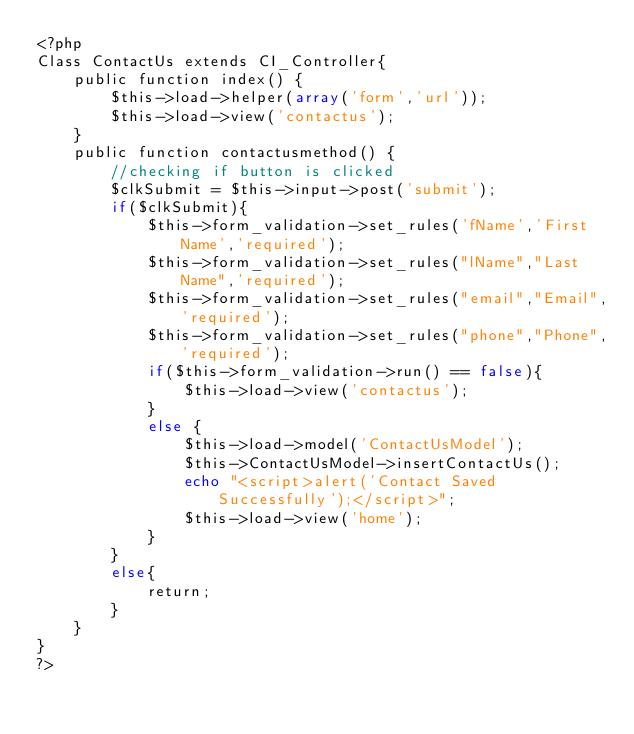Convert code to text. <code><loc_0><loc_0><loc_500><loc_500><_PHP_><?php
Class ContactUs extends CI_Controller{	
	public function index() {
		$this->load->helper(array('form','url'));
		$this->load->view('contactus');
	}
	public function contactusmethod() {
		//checking if button is clicked
		$clkSubmit = $this->input->post('submit');
		if($clkSubmit){			
			$this->form_validation->set_rules('fName','First Name','required');
			$this->form_validation->set_rules("lName","Last Name",'required');
			$this->form_validation->set_rules("email","Email",'required');
			$this->form_validation->set_rules("phone","Phone",'required');
			if($this->form_validation->run() == false){
				$this->load->view('contactus');
			}
			else {
				$this->load->model('ContactUsModel');
				$this->ContactUsModel->insertContactUs();
				echo "<script>alert('Contact Saved Successfully');</script>";
				$this->load->view('home');
			}
		}
		else{		
			return;
		}
	}
}
?></code> 